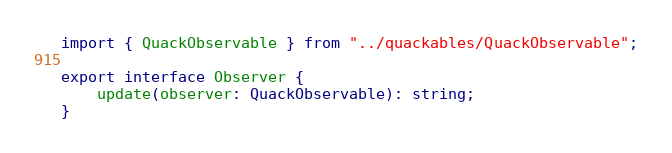<code> <loc_0><loc_0><loc_500><loc_500><_TypeScript_>import { QuackObservable } from "../quackables/QuackObservable";

export interface Observer {
    update(observer: QuackObservable): string;
}</code> 